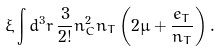<formula> <loc_0><loc_0><loc_500><loc_500>\xi \int d ^ { 3 } r \, \frac { 3 } { 2 ! } n _ { C } ^ { 2 } n _ { T } \left ( 2 \mu + \frac { e _ { T } } { n _ { T } } \right ) .</formula> 